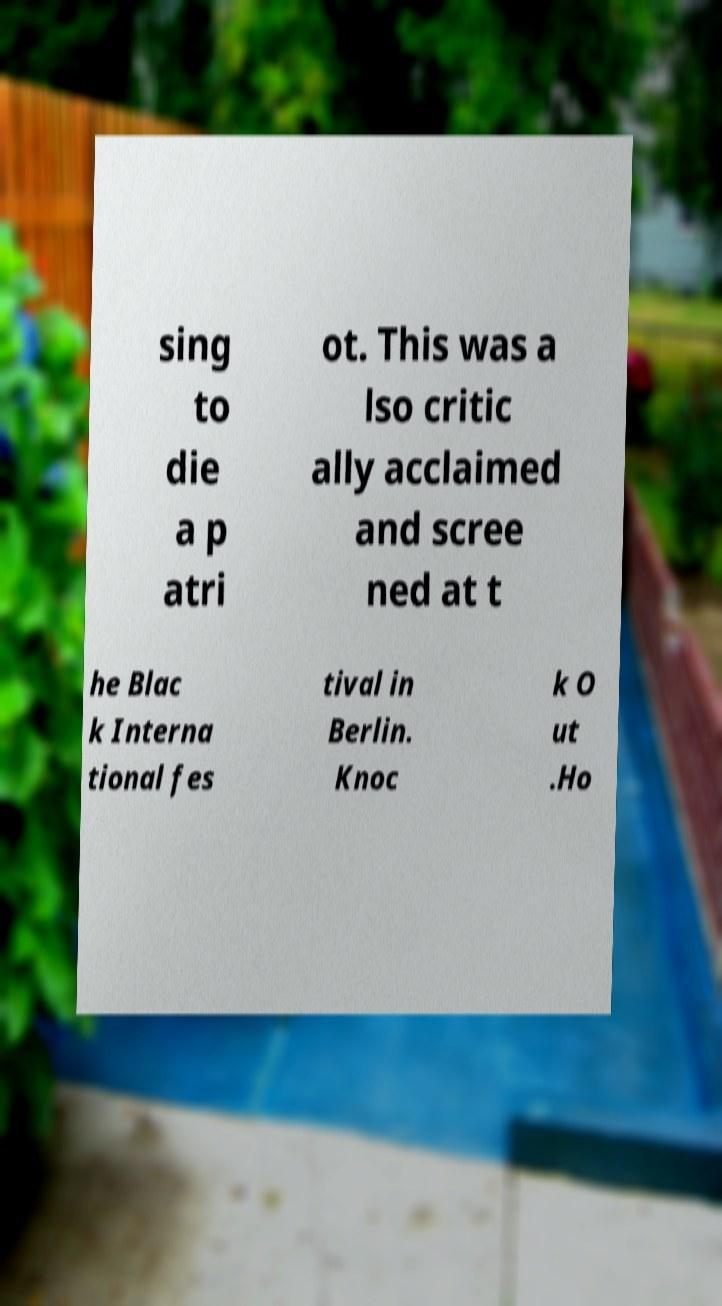For documentation purposes, I need the text within this image transcribed. Could you provide that? sing to die a p atri ot. This was a lso critic ally acclaimed and scree ned at t he Blac k Interna tional fes tival in Berlin. Knoc k O ut .Ho 